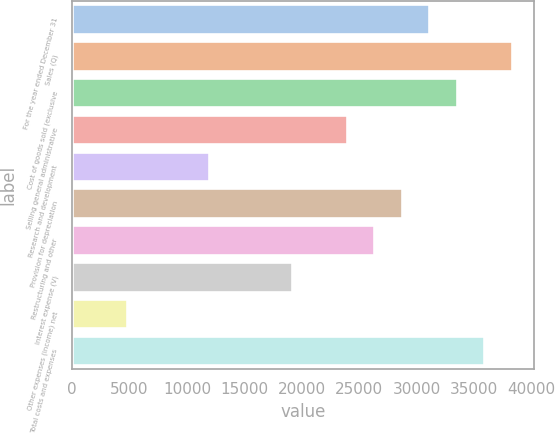<chart> <loc_0><loc_0><loc_500><loc_500><bar_chart><fcel>For the year ended December 31<fcel>Sales (Q)<fcel>Cost of goods sold (exclusive<fcel>Selling general administrative<fcel>Research and development<fcel>Provision for depreciation<fcel>Restructuring and other<fcel>Interest expense (V)<fcel>Other expenses (income) net<fcel>Total costs and expenses<nl><fcel>31077.8<fcel>38249.5<fcel>33468.3<fcel>23906<fcel>11953.1<fcel>28687.2<fcel>26296.6<fcel>19124.8<fcel>4781.37<fcel>35858.9<nl></chart> 